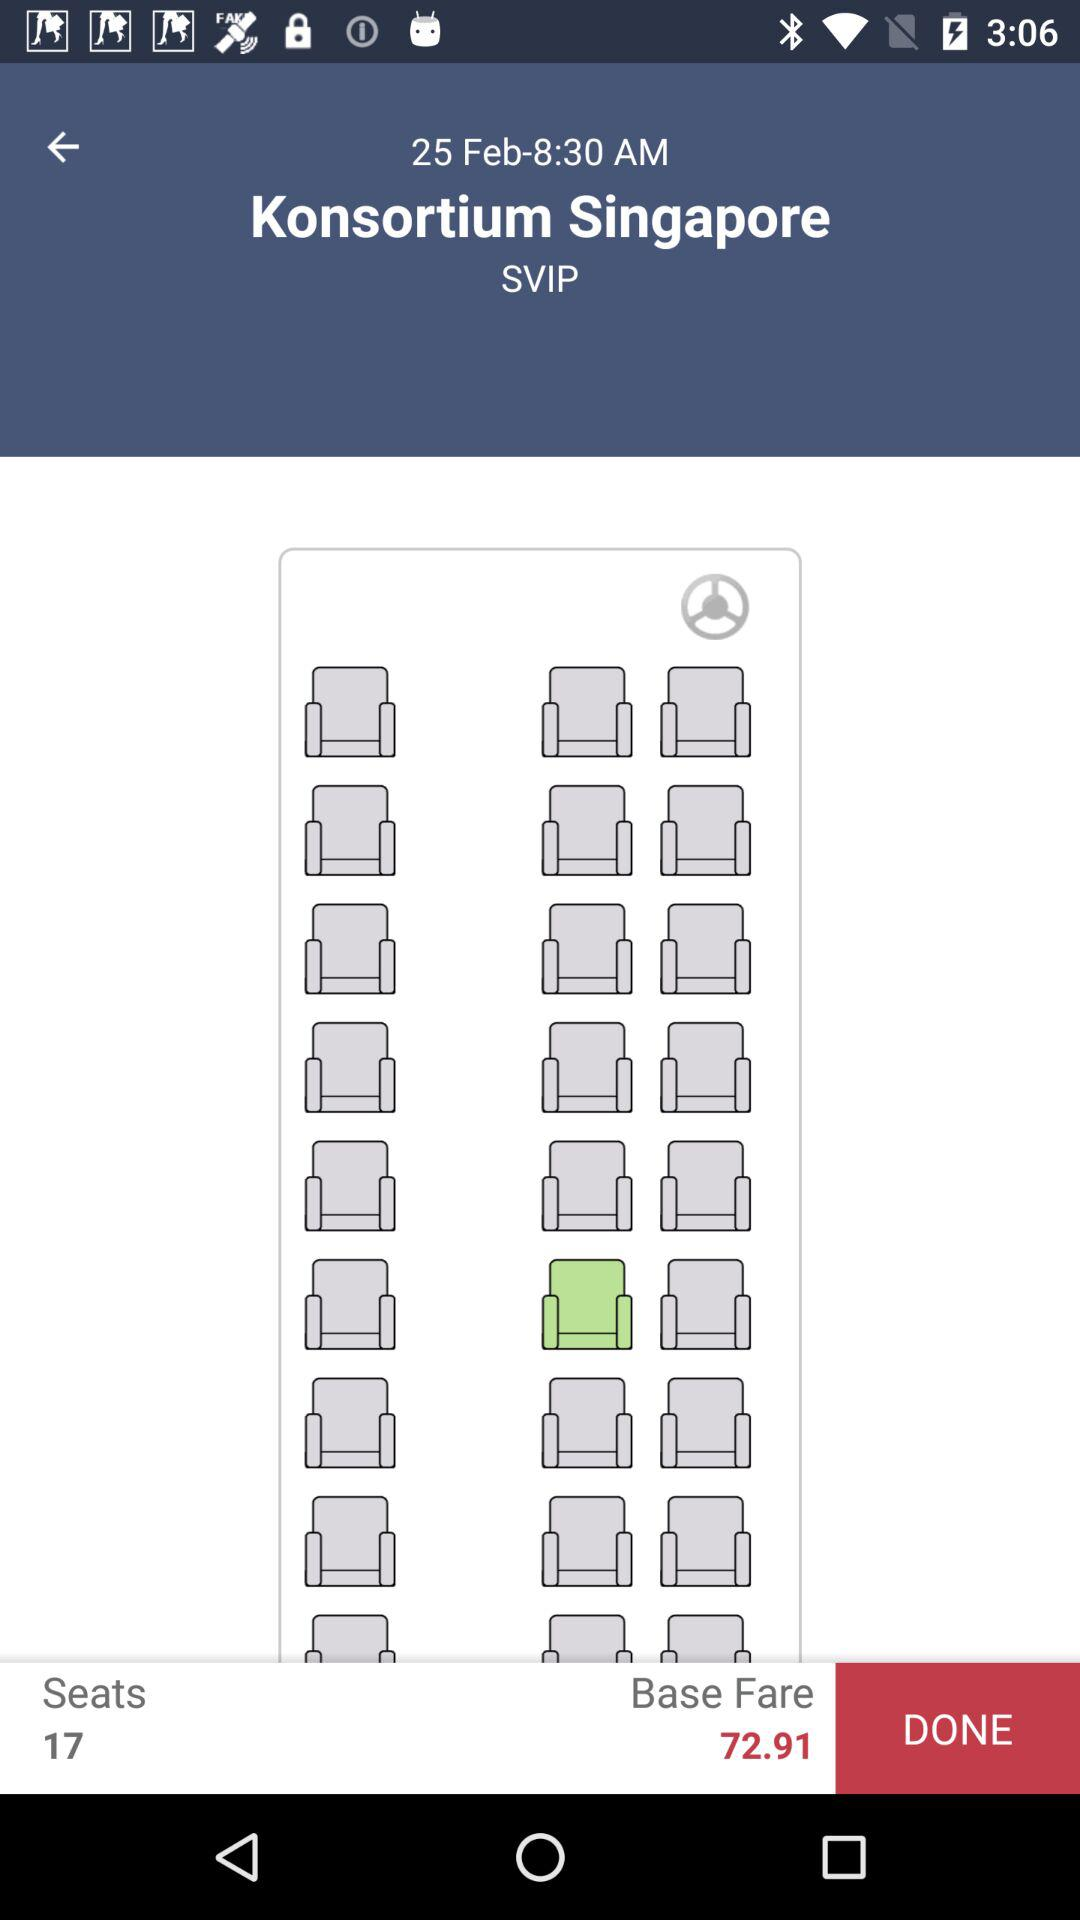How many seats are available in the first class section?
Answer the question using a single word or phrase. 17 